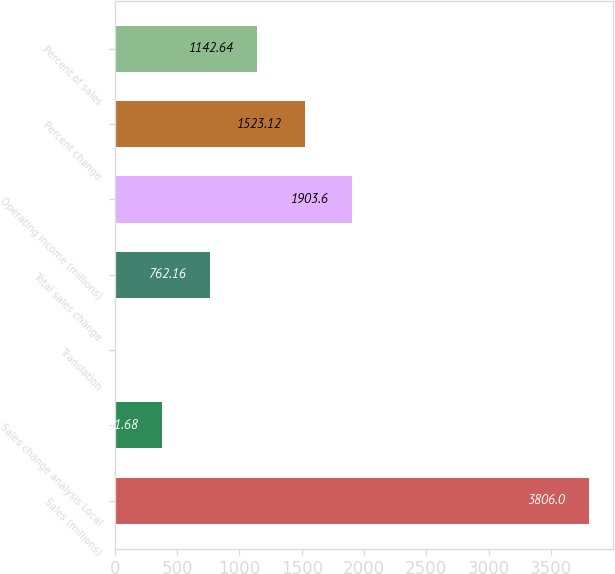Convert chart to OTSL. <chart><loc_0><loc_0><loc_500><loc_500><bar_chart><fcel>Sales (millions)<fcel>Sales change analysis Local<fcel>Translation<fcel>Total sales change<fcel>Operating income (millions)<fcel>Percent change<fcel>Percent of sales<nl><fcel>3806<fcel>381.68<fcel>1.2<fcel>762.16<fcel>1903.6<fcel>1523.12<fcel>1142.64<nl></chart> 